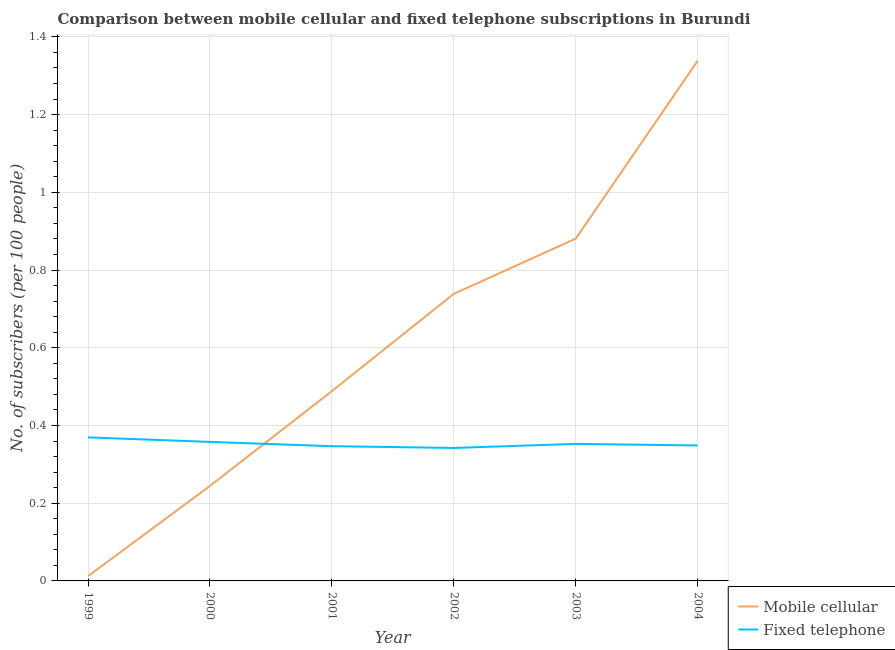Does the line corresponding to number of mobile cellular subscribers intersect with the line corresponding to number of fixed telephone subscribers?
Make the answer very short. Yes. Is the number of lines equal to the number of legend labels?
Ensure brevity in your answer.  Yes. What is the number of mobile cellular subscribers in 2002?
Give a very brief answer. 0.74. Across all years, what is the maximum number of mobile cellular subscribers?
Provide a short and direct response. 1.34. Across all years, what is the minimum number of fixed telephone subscribers?
Make the answer very short. 0.34. In which year was the number of mobile cellular subscribers maximum?
Your answer should be compact. 2004. In which year was the number of mobile cellular subscribers minimum?
Your answer should be compact. 1999. What is the total number of mobile cellular subscribers in the graph?
Make the answer very short. 3.7. What is the difference between the number of mobile cellular subscribers in 2000 and that in 2002?
Your answer should be very brief. -0.49. What is the difference between the number of fixed telephone subscribers in 1999 and the number of mobile cellular subscribers in 2004?
Your response must be concise. -0.97. What is the average number of mobile cellular subscribers per year?
Your answer should be compact. 0.62. In the year 2002, what is the difference between the number of fixed telephone subscribers and number of mobile cellular subscribers?
Your answer should be very brief. -0.4. What is the ratio of the number of fixed telephone subscribers in 2001 to that in 2004?
Ensure brevity in your answer.  0.99. Is the number of fixed telephone subscribers in 2001 less than that in 2002?
Your answer should be compact. No. Is the difference between the number of fixed telephone subscribers in 2000 and 2002 greater than the difference between the number of mobile cellular subscribers in 2000 and 2002?
Ensure brevity in your answer.  Yes. What is the difference between the highest and the second highest number of mobile cellular subscribers?
Keep it short and to the point. 0.46. What is the difference between the highest and the lowest number of fixed telephone subscribers?
Provide a short and direct response. 0.03. Does the number of mobile cellular subscribers monotonically increase over the years?
Your response must be concise. Yes. Is the number of fixed telephone subscribers strictly greater than the number of mobile cellular subscribers over the years?
Ensure brevity in your answer.  No. Is the number of fixed telephone subscribers strictly less than the number of mobile cellular subscribers over the years?
Provide a short and direct response. No. How many lines are there?
Provide a short and direct response. 2. How many years are there in the graph?
Provide a short and direct response. 6. What is the difference between two consecutive major ticks on the Y-axis?
Provide a short and direct response. 0.2. Does the graph contain any zero values?
Keep it short and to the point. No. Where does the legend appear in the graph?
Provide a short and direct response. Bottom right. How are the legend labels stacked?
Provide a succinct answer. Vertical. What is the title of the graph?
Your answer should be very brief. Comparison between mobile cellular and fixed telephone subscriptions in Burundi. What is the label or title of the X-axis?
Your answer should be very brief. Year. What is the label or title of the Y-axis?
Provide a short and direct response. No. of subscribers (per 100 people). What is the No. of subscribers (per 100 people) in Mobile cellular in 1999?
Keep it short and to the point. 0.01. What is the No. of subscribers (per 100 people) in Fixed telephone in 1999?
Your response must be concise. 0.37. What is the No. of subscribers (per 100 people) in Mobile cellular in 2000?
Your answer should be very brief. 0.24. What is the No. of subscribers (per 100 people) of Fixed telephone in 2000?
Give a very brief answer. 0.36. What is the No. of subscribers (per 100 people) in Mobile cellular in 2001?
Your response must be concise. 0.49. What is the No. of subscribers (per 100 people) of Fixed telephone in 2001?
Your response must be concise. 0.35. What is the No. of subscribers (per 100 people) of Mobile cellular in 2002?
Give a very brief answer. 0.74. What is the No. of subscribers (per 100 people) in Fixed telephone in 2002?
Make the answer very short. 0.34. What is the No. of subscribers (per 100 people) of Mobile cellular in 2003?
Keep it short and to the point. 0.88. What is the No. of subscribers (per 100 people) of Fixed telephone in 2003?
Keep it short and to the point. 0.35. What is the No. of subscribers (per 100 people) in Mobile cellular in 2004?
Your answer should be very brief. 1.34. What is the No. of subscribers (per 100 people) in Fixed telephone in 2004?
Provide a short and direct response. 0.35. Across all years, what is the maximum No. of subscribers (per 100 people) of Mobile cellular?
Give a very brief answer. 1.34. Across all years, what is the maximum No. of subscribers (per 100 people) in Fixed telephone?
Provide a short and direct response. 0.37. Across all years, what is the minimum No. of subscribers (per 100 people) in Mobile cellular?
Provide a short and direct response. 0.01. Across all years, what is the minimum No. of subscribers (per 100 people) in Fixed telephone?
Provide a short and direct response. 0.34. What is the total No. of subscribers (per 100 people) in Mobile cellular in the graph?
Make the answer very short. 3.7. What is the total No. of subscribers (per 100 people) in Fixed telephone in the graph?
Your answer should be compact. 2.12. What is the difference between the No. of subscribers (per 100 people) in Mobile cellular in 1999 and that in 2000?
Provide a succinct answer. -0.23. What is the difference between the No. of subscribers (per 100 people) in Fixed telephone in 1999 and that in 2000?
Ensure brevity in your answer.  0.01. What is the difference between the No. of subscribers (per 100 people) in Mobile cellular in 1999 and that in 2001?
Offer a terse response. -0.48. What is the difference between the No. of subscribers (per 100 people) of Fixed telephone in 1999 and that in 2001?
Provide a succinct answer. 0.02. What is the difference between the No. of subscribers (per 100 people) of Mobile cellular in 1999 and that in 2002?
Provide a succinct answer. -0.73. What is the difference between the No. of subscribers (per 100 people) of Fixed telephone in 1999 and that in 2002?
Your response must be concise. 0.03. What is the difference between the No. of subscribers (per 100 people) in Mobile cellular in 1999 and that in 2003?
Ensure brevity in your answer.  -0.87. What is the difference between the No. of subscribers (per 100 people) of Fixed telephone in 1999 and that in 2003?
Make the answer very short. 0.02. What is the difference between the No. of subscribers (per 100 people) of Mobile cellular in 1999 and that in 2004?
Offer a terse response. -1.33. What is the difference between the No. of subscribers (per 100 people) in Fixed telephone in 1999 and that in 2004?
Offer a terse response. 0.02. What is the difference between the No. of subscribers (per 100 people) in Mobile cellular in 2000 and that in 2001?
Your answer should be very brief. -0.24. What is the difference between the No. of subscribers (per 100 people) in Fixed telephone in 2000 and that in 2001?
Ensure brevity in your answer.  0.01. What is the difference between the No. of subscribers (per 100 people) of Mobile cellular in 2000 and that in 2002?
Offer a terse response. -0.49. What is the difference between the No. of subscribers (per 100 people) in Fixed telephone in 2000 and that in 2002?
Give a very brief answer. 0.02. What is the difference between the No. of subscribers (per 100 people) in Mobile cellular in 2000 and that in 2003?
Provide a succinct answer. -0.64. What is the difference between the No. of subscribers (per 100 people) of Fixed telephone in 2000 and that in 2003?
Offer a terse response. 0.01. What is the difference between the No. of subscribers (per 100 people) of Mobile cellular in 2000 and that in 2004?
Offer a terse response. -1.09. What is the difference between the No. of subscribers (per 100 people) in Fixed telephone in 2000 and that in 2004?
Your answer should be compact. 0.01. What is the difference between the No. of subscribers (per 100 people) in Mobile cellular in 2001 and that in 2002?
Provide a succinct answer. -0.25. What is the difference between the No. of subscribers (per 100 people) in Fixed telephone in 2001 and that in 2002?
Your answer should be compact. 0. What is the difference between the No. of subscribers (per 100 people) of Mobile cellular in 2001 and that in 2003?
Your answer should be very brief. -0.39. What is the difference between the No. of subscribers (per 100 people) in Fixed telephone in 2001 and that in 2003?
Offer a terse response. -0.01. What is the difference between the No. of subscribers (per 100 people) of Mobile cellular in 2001 and that in 2004?
Offer a terse response. -0.85. What is the difference between the No. of subscribers (per 100 people) in Fixed telephone in 2001 and that in 2004?
Offer a very short reply. -0. What is the difference between the No. of subscribers (per 100 people) in Mobile cellular in 2002 and that in 2003?
Ensure brevity in your answer.  -0.14. What is the difference between the No. of subscribers (per 100 people) of Fixed telephone in 2002 and that in 2003?
Give a very brief answer. -0.01. What is the difference between the No. of subscribers (per 100 people) in Mobile cellular in 2002 and that in 2004?
Your answer should be very brief. -0.6. What is the difference between the No. of subscribers (per 100 people) of Fixed telephone in 2002 and that in 2004?
Provide a succinct answer. -0.01. What is the difference between the No. of subscribers (per 100 people) of Mobile cellular in 2003 and that in 2004?
Make the answer very short. -0.46. What is the difference between the No. of subscribers (per 100 people) of Fixed telephone in 2003 and that in 2004?
Keep it short and to the point. 0. What is the difference between the No. of subscribers (per 100 people) in Mobile cellular in 1999 and the No. of subscribers (per 100 people) in Fixed telephone in 2000?
Ensure brevity in your answer.  -0.35. What is the difference between the No. of subscribers (per 100 people) in Mobile cellular in 1999 and the No. of subscribers (per 100 people) in Fixed telephone in 2001?
Ensure brevity in your answer.  -0.33. What is the difference between the No. of subscribers (per 100 people) of Mobile cellular in 1999 and the No. of subscribers (per 100 people) of Fixed telephone in 2002?
Your response must be concise. -0.33. What is the difference between the No. of subscribers (per 100 people) in Mobile cellular in 1999 and the No. of subscribers (per 100 people) in Fixed telephone in 2003?
Make the answer very short. -0.34. What is the difference between the No. of subscribers (per 100 people) of Mobile cellular in 1999 and the No. of subscribers (per 100 people) of Fixed telephone in 2004?
Provide a succinct answer. -0.34. What is the difference between the No. of subscribers (per 100 people) of Mobile cellular in 2000 and the No. of subscribers (per 100 people) of Fixed telephone in 2001?
Offer a very short reply. -0.1. What is the difference between the No. of subscribers (per 100 people) of Mobile cellular in 2000 and the No. of subscribers (per 100 people) of Fixed telephone in 2002?
Your answer should be very brief. -0.1. What is the difference between the No. of subscribers (per 100 people) in Mobile cellular in 2000 and the No. of subscribers (per 100 people) in Fixed telephone in 2003?
Ensure brevity in your answer.  -0.11. What is the difference between the No. of subscribers (per 100 people) in Mobile cellular in 2000 and the No. of subscribers (per 100 people) in Fixed telephone in 2004?
Offer a very short reply. -0.1. What is the difference between the No. of subscribers (per 100 people) of Mobile cellular in 2001 and the No. of subscribers (per 100 people) of Fixed telephone in 2002?
Provide a succinct answer. 0.15. What is the difference between the No. of subscribers (per 100 people) of Mobile cellular in 2001 and the No. of subscribers (per 100 people) of Fixed telephone in 2003?
Give a very brief answer. 0.14. What is the difference between the No. of subscribers (per 100 people) of Mobile cellular in 2001 and the No. of subscribers (per 100 people) of Fixed telephone in 2004?
Ensure brevity in your answer.  0.14. What is the difference between the No. of subscribers (per 100 people) of Mobile cellular in 2002 and the No. of subscribers (per 100 people) of Fixed telephone in 2003?
Give a very brief answer. 0.39. What is the difference between the No. of subscribers (per 100 people) of Mobile cellular in 2002 and the No. of subscribers (per 100 people) of Fixed telephone in 2004?
Give a very brief answer. 0.39. What is the difference between the No. of subscribers (per 100 people) of Mobile cellular in 2003 and the No. of subscribers (per 100 people) of Fixed telephone in 2004?
Offer a very short reply. 0.53. What is the average No. of subscribers (per 100 people) of Mobile cellular per year?
Offer a terse response. 0.62. What is the average No. of subscribers (per 100 people) in Fixed telephone per year?
Offer a very short reply. 0.35. In the year 1999, what is the difference between the No. of subscribers (per 100 people) of Mobile cellular and No. of subscribers (per 100 people) of Fixed telephone?
Offer a terse response. -0.36. In the year 2000, what is the difference between the No. of subscribers (per 100 people) in Mobile cellular and No. of subscribers (per 100 people) in Fixed telephone?
Ensure brevity in your answer.  -0.11. In the year 2001, what is the difference between the No. of subscribers (per 100 people) of Mobile cellular and No. of subscribers (per 100 people) of Fixed telephone?
Offer a terse response. 0.14. In the year 2002, what is the difference between the No. of subscribers (per 100 people) in Mobile cellular and No. of subscribers (per 100 people) in Fixed telephone?
Make the answer very short. 0.4. In the year 2003, what is the difference between the No. of subscribers (per 100 people) of Mobile cellular and No. of subscribers (per 100 people) of Fixed telephone?
Provide a succinct answer. 0.53. In the year 2004, what is the difference between the No. of subscribers (per 100 people) in Mobile cellular and No. of subscribers (per 100 people) in Fixed telephone?
Ensure brevity in your answer.  0.99. What is the ratio of the No. of subscribers (per 100 people) of Mobile cellular in 1999 to that in 2000?
Your answer should be compact. 0.05. What is the ratio of the No. of subscribers (per 100 people) in Fixed telephone in 1999 to that in 2000?
Make the answer very short. 1.03. What is the ratio of the No. of subscribers (per 100 people) in Mobile cellular in 1999 to that in 2001?
Offer a very short reply. 0.03. What is the ratio of the No. of subscribers (per 100 people) in Fixed telephone in 1999 to that in 2001?
Keep it short and to the point. 1.07. What is the ratio of the No. of subscribers (per 100 people) in Mobile cellular in 1999 to that in 2002?
Offer a terse response. 0.02. What is the ratio of the No. of subscribers (per 100 people) in Fixed telephone in 1999 to that in 2002?
Offer a very short reply. 1.08. What is the ratio of the No. of subscribers (per 100 people) of Mobile cellular in 1999 to that in 2003?
Offer a terse response. 0.01. What is the ratio of the No. of subscribers (per 100 people) of Fixed telephone in 1999 to that in 2003?
Keep it short and to the point. 1.05. What is the ratio of the No. of subscribers (per 100 people) in Mobile cellular in 1999 to that in 2004?
Your answer should be compact. 0.01. What is the ratio of the No. of subscribers (per 100 people) in Fixed telephone in 1999 to that in 2004?
Make the answer very short. 1.06. What is the ratio of the No. of subscribers (per 100 people) of Mobile cellular in 2000 to that in 2001?
Ensure brevity in your answer.  0.5. What is the ratio of the No. of subscribers (per 100 people) of Fixed telephone in 2000 to that in 2001?
Your response must be concise. 1.03. What is the ratio of the No. of subscribers (per 100 people) of Mobile cellular in 2000 to that in 2002?
Make the answer very short. 0.33. What is the ratio of the No. of subscribers (per 100 people) in Fixed telephone in 2000 to that in 2002?
Keep it short and to the point. 1.05. What is the ratio of the No. of subscribers (per 100 people) in Mobile cellular in 2000 to that in 2003?
Make the answer very short. 0.28. What is the ratio of the No. of subscribers (per 100 people) in Fixed telephone in 2000 to that in 2003?
Provide a short and direct response. 1.01. What is the ratio of the No. of subscribers (per 100 people) of Mobile cellular in 2000 to that in 2004?
Keep it short and to the point. 0.18. What is the ratio of the No. of subscribers (per 100 people) of Fixed telephone in 2000 to that in 2004?
Your answer should be very brief. 1.03. What is the ratio of the No. of subscribers (per 100 people) of Mobile cellular in 2001 to that in 2002?
Your answer should be compact. 0.66. What is the ratio of the No. of subscribers (per 100 people) of Fixed telephone in 2001 to that in 2002?
Ensure brevity in your answer.  1.01. What is the ratio of the No. of subscribers (per 100 people) of Mobile cellular in 2001 to that in 2003?
Your answer should be very brief. 0.55. What is the ratio of the No. of subscribers (per 100 people) in Fixed telephone in 2001 to that in 2003?
Ensure brevity in your answer.  0.98. What is the ratio of the No. of subscribers (per 100 people) of Mobile cellular in 2001 to that in 2004?
Keep it short and to the point. 0.36. What is the ratio of the No. of subscribers (per 100 people) of Fixed telephone in 2001 to that in 2004?
Offer a terse response. 0.99. What is the ratio of the No. of subscribers (per 100 people) in Mobile cellular in 2002 to that in 2003?
Give a very brief answer. 0.84. What is the ratio of the No. of subscribers (per 100 people) in Fixed telephone in 2002 to that in 2003?
Offer a terse response. 0.97. What is the ratio of the No. of subscribers (per 100 people) of Mobile cellular in 2002 to that in 2004?
Your answer should be very brief. 0.55. What is the ratio of the No. of subscribers (per 100 people) in Fixed telephone in 2002 to that in 2004?
Offer a very short reply. 0.98. What is the ratio of the No. of subscribers (per 100 people) of Mobile cellular in 2003 to that in 2004?
Your answer should be very brief. 0.66. What is the ratio of the No. of subscribers (per 100 people) of Fixed telephone in 2003 to that in 2004?
Your answer should be compact. 1.01. What is the difference between the highest and the second highest No. of subscribers (per 100 people) in Mobile cellular?
Make the answer very short. 0.46. What is the difference between the highest and the second highest No. of subscribers (per 100 people) in Fixed telephone?
Provide a succinct answer. 0.01. What is the difference between the highest and the lowest No. of subscribers (per 100 people) in Mobile cellular?
Provide a short and direct response. 1.33. What is the difference between the highest and the lowest No. of subscribers (per 100 people) in Fixed telephone?
Ensure brevity in your answer.  0.03. 